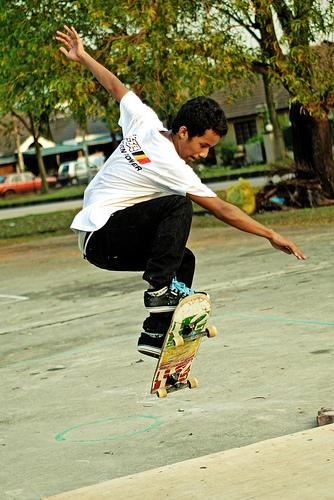Give a detailed description of the young skateboarder's attire. The boy is wearing a white short-sleeved shirt with a yellow, black, and red pattern, black jeans, and shoes with light blue laces. Describe the appearance of the skateboard being used by the young man. The skateboard has a multi-colored bottom with colors including white, green, yellow, and red, and tan-colored wheels. Explain the main focus of this image along with some supporting details about the scene. The main focus of the image is a young man with dark hair doing a skateboard trick in the air, with trees, cars, and a blue circle in the background. Mention the objects present in the background of the image. In the background, there are tall green trees, a red car, a yellow bag of trash, and a blue circle on the ground. Mention the colors and patterns present on the young man's clothes and skateboard. His shirt has a yellow, black, and red pattern, light blue shoelaces, and a multi-colored skateboard with white, green, yellow, and red. Describe the hairstyle and color of the young man on the skateboard. The young man has dark, black-colored hair. Provide a brief overview of the main action taking place in the photo. A young man with dark hair, wearing a white shirt and black pants, is performing a skateboard trick in the air. 